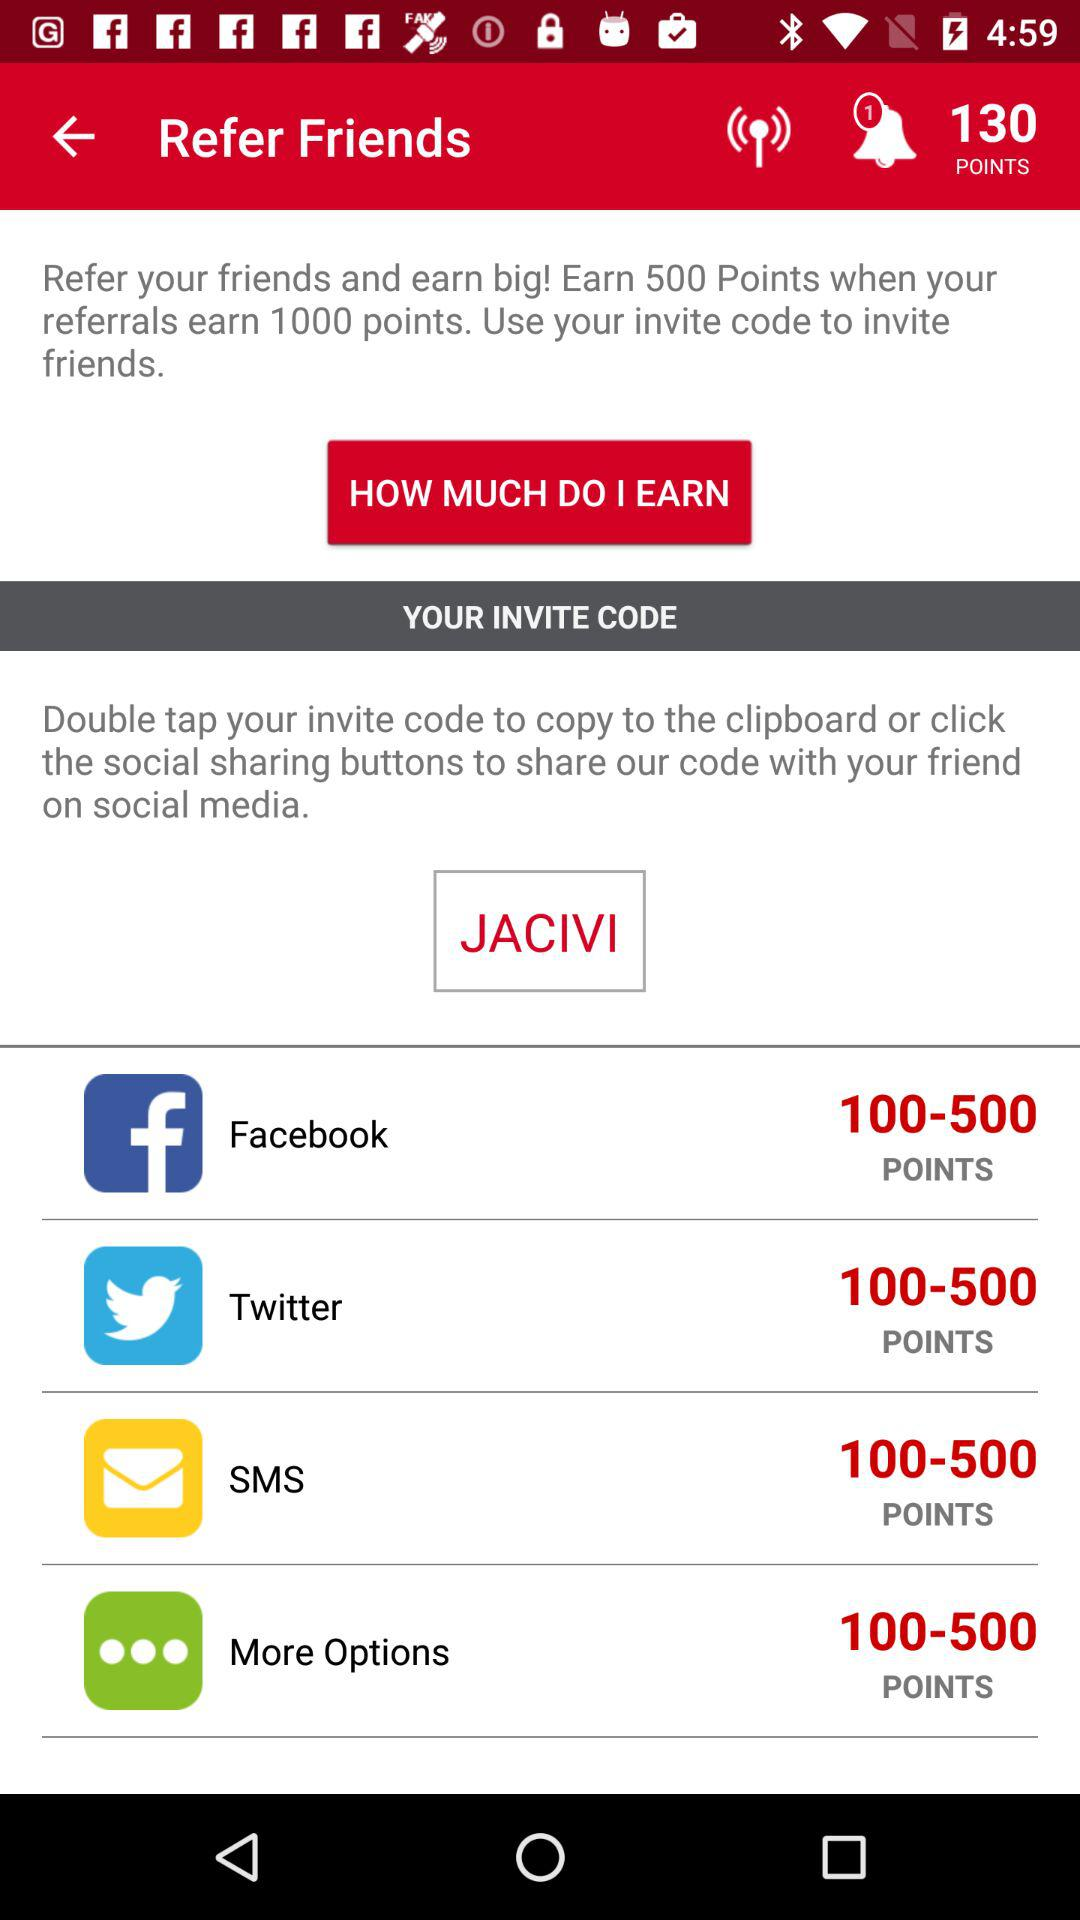How many points do I earn if my referrals earn 1000 points?
Answer the question using a single word or phrase. 500 